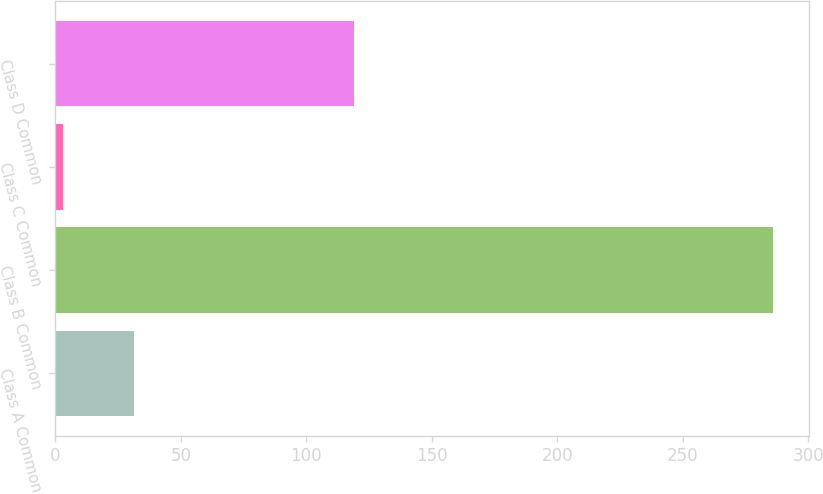<chart> <loc_0><loc_0><loc_500><loc_500><bar_chart><fcel>Class A Common<fcel>Class B Common<fcel>Class C Common<fcel>Class D Common<nl><fcel>31.3<fcel>286<fcel>3<fcel>119<nl></chart> 